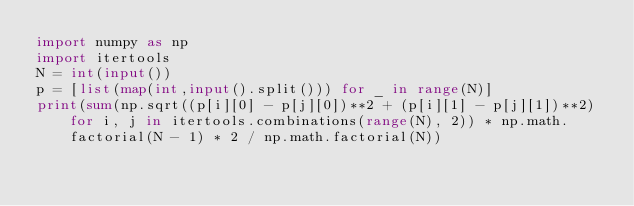Convert code to text. <code><loc_0><loc_0><loc_500><loc_500><_Python_>import numpy as np
import itertools
N = int(input())
p = [list(map(int,input().split())) for _ in range(N)]
print(sum(np.sqrt((p[i][0] - p[j][0])**2 + (p[i][1] - p[j][1])**2) for i, j in itertools.combinations(range(N), 2)) * np.math.factorial(N - 1) * 2 / np.math.factorial(N))</code> 